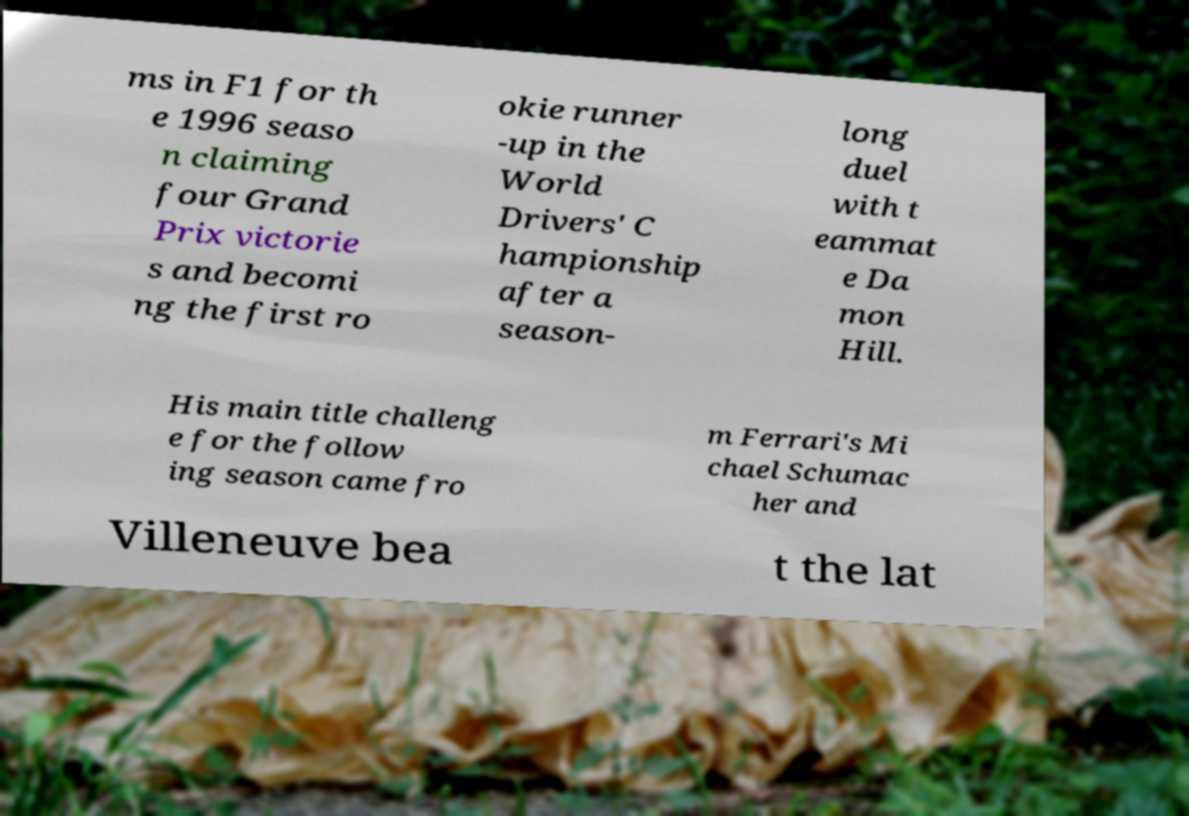What messages or text are displayed in this image? I need them in a readable, typed format. ms in F1 for th e 1996 seaso n claiming four Grand Prix victorie s and becomi ng the first ro okie runner -up in the World Drivers' C hampionship after a season- long duel with t eammat e Da mon Hill. His main title challeng e for the follow ing season came fro m Ferrari's Mi chael Schumac her and Villeneuve bea t the lat 